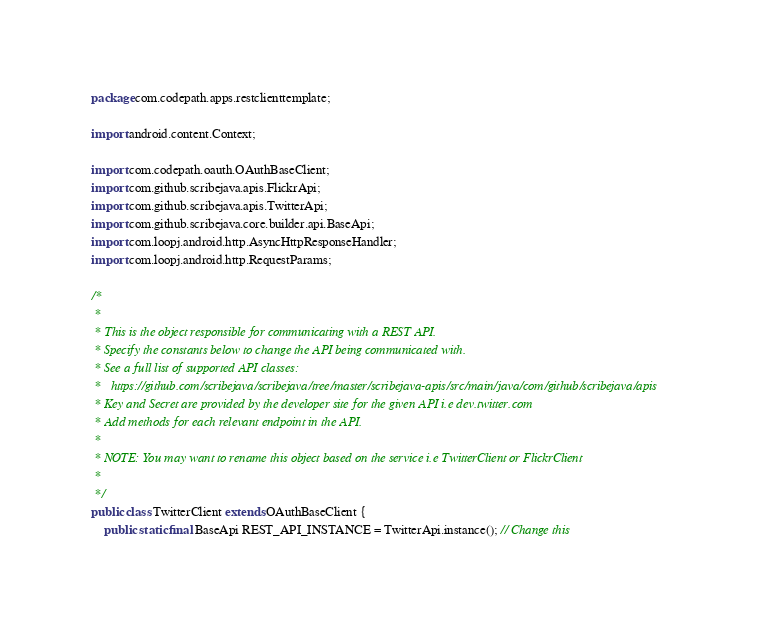Convert code to text. <code><loc_0><loc_0><loc_500><loc_500><_Java_>package com.codepath.apps.restclienttemplate;

import android.content.Context;

import com.codepath.oauth.OAuthBaseClient;
import com.github.scribejava.apis.FlickrApi;
import com.github.scribejava.apis.TwitterApi;
import com.github.scribejava.core.builder.api.BaseApi;
import com.loopj.android.http.AsyncHttpResponseHandler;
import com.loopj.android.http.RequestParams;

/*
 * 
 * This is the object responsible for communicating with a REST API. 
 * Specify the constants below to change the API being communicated with.
 * See a full list of supported API classes: 
 *   https://github.com/scribejava/scribejava/tree/master/scribejava-apis/src/main/java/com/github/scribejava/apis
 * Key and Secret are provided by the developer site for the given API i.e dev.twitter.com
 * Add methods for each relevant endpoint in the API.
 * 
 * NOTE: You may want to rename this object based on the service i.e TwitterClient or FlickrClient
 * 
 */
public class TwitterClient extends OAuthBaseClient {
	public static final BaseApi REST_API_INSTANCE = TwitterApi.instance(); // Change this</code> 